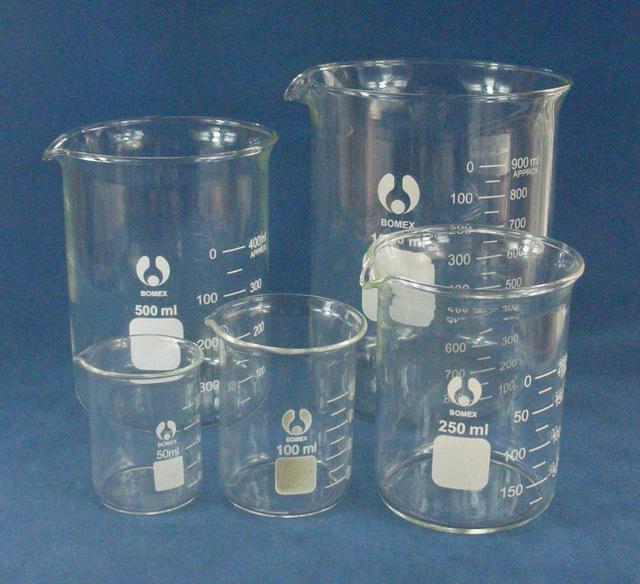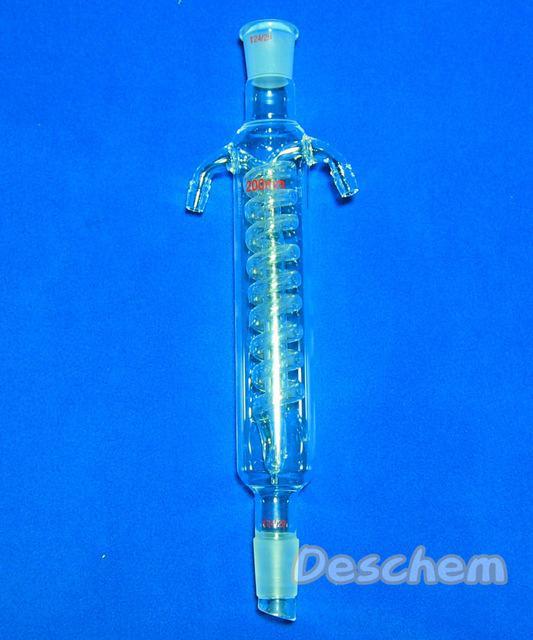The first image is the image on the left, the second image is the image on the right. Considering the images on both sides, is "There are at least four beaker." valid? Answer yes or no. Yes. The first image is the image on the left, the second image is the image on the right. For the images shown, is this caption "Four or more beakers are visible." true? Answer yes or no. Yes. 